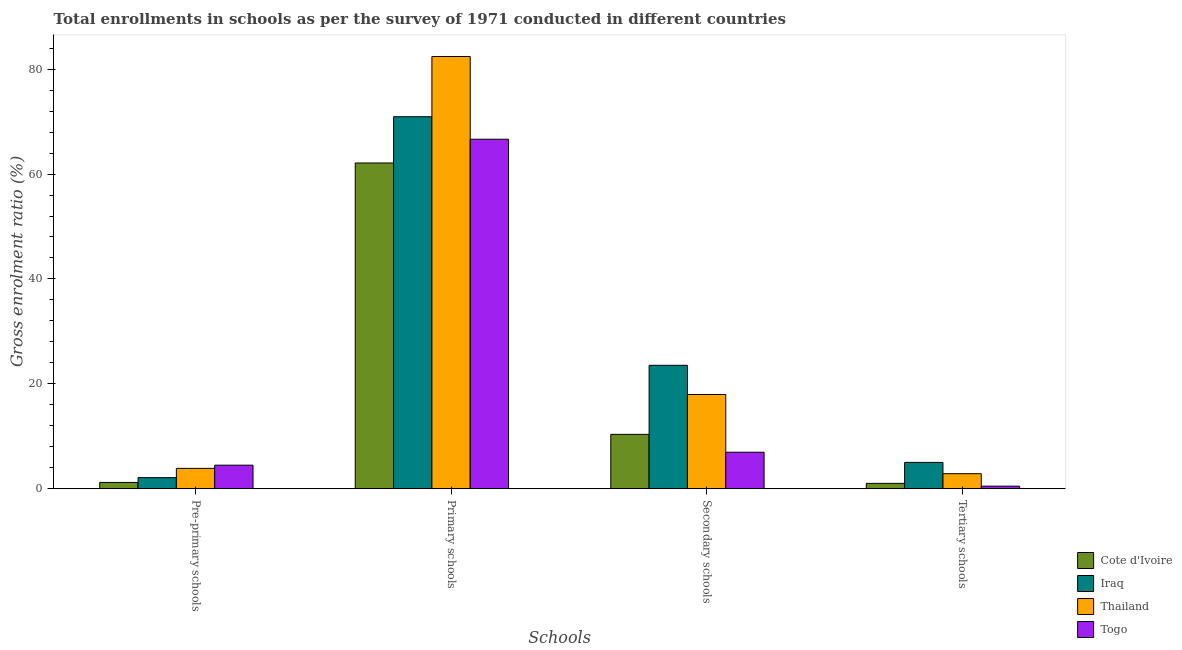How many bars are there on the 1st tick from the right?
Your response must be concise. 4. What is the label of the 2nd group of bars from the left?
Make the answer very short. Primary schools. What is the gross enrolment ratio in primary schools in Thailand?
Ensure brevity in your answer.  82.42. Across all countries, what is the maximum gross enrolment ratio in secondary schools?
Your answer should be very brief. 23.53. Across all countries, what is the minimum gross enrolment ratio in secondary schools?
Offer a very short reply. 6.95. In which country was the gross enrolment ratio in pre-primary schools maximum?
Provide a succinct answer. Togo. In which country was the gross enrolment ratio in secondary schools minimum?
Offer a very short reply. Togo. What is the total gross enrolment ratio in primary schools in the graph?
Provide a succinct answer. 282.12. What is the difference between the gross enrolment ratio in tertiary schools in Thailand and that in Cote d'Ivoire?
Your response must be concise. 1.85. What is the difference between the gross enrolment ratio in secondary schools in Thailand and the gross enrolment ratio in primary schools in Iraq?
Your response must be concise. -52.98. What is the average gross enrolment ratio in primary schools per country?
Give a very brief answer. 70.53. What is the difference between the gross enrolment ratio in primary schools and gross enrolment ratio in tertiary schools in Iraq?
Provide a short and direct response. 65.92. What is the ratio of the gross enrolment ratio in primary schools in Cote d'Ivoire to that in Thailand?
Your answer should be compact. 0.75. Is the gross enrolment ratio in tertiary schools in Togo less than that in Thailand?
Provide a short and direct response. Yes. What is the difference between the highest and the second highest gross enrolment ratio in pre-primary schools?
Make the answer very short. 0.61. What is the difference between the highest and the lowest gross enrolment ratio in tertiary schools?
Ensure brevity in your answer.  4.53. Is the sum of the gross enrolment ratio in primary schools in Thailand and Togo greater than the maximum gross enrolment ratio in tertiary schools across all countries?
Provide a short and direct response. Yes. Is it the case that in every country, the sum of the gross enrolment ratio in primary schools and gross enrolment ratio in tertiary schools is greater than the sum of gross enrolment ratio in pre-primary schools and gross enrolment ratio in secondary schools?
Your response must be concise. Yes. What does the 2nd bar from the left in Pre-primary schools represents?
Your answer should be very brief. Iraq. What does the 3rd bar from the right in Primary schools represents?
Your response must be concise. Iraq. How many bars are there?
Your answer should be very brief. 16. Does the graph contain grids?
Offer a very short reply. No. What is the title of the graph?
Your response must be concise. Total enrollments in schools as per the survey of 1971 conducted in different countries. What is the label or title of the X-axis?
Give a very brief answer. Schools. What is the Gross enrolment ratio (%) of Cote d'Ivoire in Pre-primary schools?
Your answer should be compact. 1.19. What is the Gross enrolment ratio (%) of Iraq in Pre-primary schools?
Give a very brief answer. 2.1. What is the Gross enrolment ratio (%) of Thailand in Pre-primary schools?
Keep it short and to the point. 3.87. What is the Gross enrolment ratio (%) of Togo in Pre-primary schools?
Give a very brief answer. 4.48. What is the Gross enrolment ratio (%) of Cote d'Ivoire in Primary schools?
Make the answer very short. 62.12. What is the Gross enrolment ratio (%) in Iraq in Primary schools?
Your response must be concise. 70.94. What is the Gross enrolment ratio (%) in Thailand in Primary schools?
Your answer should be compact. 82.42. What is the Gross enrolment ratio (%) in Togo in Primary schools?
Offer a terse response. 66.64. What is the Gross enrolment ratio (%) of Cote d'Ivoire in Secondary schools?
Your answer should be compact. 10.36. What is the Gross enrolment ratio (%) in Iraq in Secondary schools?
Your response must be concise. 23.53. What is the Gross enrolment ratio (%) in Thailand in Secondary schools?
Offer a terse response. 17.96. What is the Gross enrolment ratio (%) in Togo in Secondary schools?
Keep it short and to the point. 6.95. What is the Gross enrolment ratio (%) in Cote d'Ivoire in Tertiary schools?
Give a very brief answer. 1.01. What is the Gross enrolment ratio (%) in Iraq in Tertiary schools?
Your answer should be very brief. 5.01. What is the Gross enrolment ratio (%) in Thailand in Tertiary schools?
Make the answer very short. 2.86. What is the Gross enrolment ratio (%) of Togo in Tertiary schools?
Your answer should be very brief. 0.48. Across all Schools, what is the maximum Gross enrolment ratio (%) in Cote d'Ivoire?
Offer a very short reply. 62.12. Across all Schools, what is the maximum Gross enrolment ratio (%) of Iraq?
Your answer should be very brief. 70.94. Across all Schools, what is the maximum Gross enrolment ratio (%) of Thailand?
Keep it short and to the point. 82.42. Across all Schools, what is the maximum Gross enrolment ratio (%) in Togo?
Provide a succinct answer. 66.64. Across all Schools, what is the minimum Gross enrolment ratio (%) of Cote d'Ivoire?
Provide a short and direct response. 1.01. Across all Schools, what is the minimum Gross enrolment ratio (%) in Iraq?
Offer a very short reply. 2.1. Across all Schools, what is the minimum Gross enrolment ratio (%) in Thailand?
Give a very brief answer. 2.86. Across all Schools, what is the minimum Gross enrolment ratio (%) in Togo?
Provide a short and direct response. 0.48. What is the total Gross enrolment ratio (%) in Cote d'Ivoire in the graph?
Your answer should be very brief. 74.67. What is the total Gross enrolment ratio (%) in Iraq in the graph?
Offer a terse response. 101.58. What is the total Gross enrolment ratio (%) of Thailand in the graph?
Give a very brief answer. 107.12. What is the total Gross enrolment ratio (%) of Togo in the graph?
Your answer should be very brief. 78.55. What is the difference between the Gross enrolment ratio (%) in Cote d'Ivoire in Pre-primary schools and that in Primary schools?
Provide a succinct answer. -60.93. What is the difference between the Gross enrolment ratio (%) of Iraq in Pre-primary schools and that in Primary schools?
Offer a terse response. -68.83. What is the difference between the Gross enrolment ratio (%) of Thailand in Pre-primary schools and that in Primary schools?
Your answer should be very brief. -78.55. What is the difference between the Gross enrolment ratio (%) in Togo in Pre-primary schools and that in Primary schools?
Provide a succinct answer. -62.16. What is the difference between the Gross enrolment ratio (%) of Cote d'Ivoire in Pre-primary schools and that in Secondary schools?
Your response must be concise. -9.17. What is the difference between the Gross enrolment ratio (%) of Iraq in Pre-primary schools and that in Secondary schools?
Make the answer very short. -21.42. What is the difference between the Gross enrolment ratio (%) in Thailand in Pre-primary schools and that in Secondary schools?
Your answer should be very brief. -14.09. What is the difference between the Gross enrolment ratio (%) of Togo in Pre-primary schools and that in Secondary schools?
Ensure brevity in your answer.  -2.47. What is the difference between the Gross enrolment ratio (%) in Cote d'Ivoire in Pre-primary schools and that in Tertiary schools?
Provide a short and direct response. 0.18. What is the difference between the Gross enrolment ratio (%) of Iraq in Pre-primary schools and that in Tertiary schools?
Provide a succinct answer. -2.91. What is the difference between the Gross enrolment ratio (%) of Thailand in Pre-primary schools and that in Tertiary schools?
Offer a terse response. 1.02. What is the difference between the Gross enrolment ratio (%) of Togo in Pre-primary schools and that in Tertiary schools?
Offer a very short reply. 4. What is the difference between the Gross enrolment ratio (%) in Cote d'Ivoire in Primary schools and that in Secondary schools?
Your response must be concise. 51.76. What is the difference between the Gross enrolment ratio (%) in Iraq in Primary schools and that in Secondary schools?
Give a very brief answer. 47.41. What is the difference between the Gross enrolment ratio (%) of Thailand in Primary schools and that in Secondary schools?
Your answer should be compact. 64.46. What is the difference between the Gross enrolment ratio (%) of Togo in Primary schools and that in Secondary schools?
Offer a very short reply. 59.69. What is the difference between the Gross enrolment ratio (%) in Cote d'Ivoire in Primary schools and that in Tertiary schools?
Your response must be concise. 61.1. What is the difference between the Gross enrolment ratio (%) of Iraq in Primary schools and that in Tertiary schools?
Give a very brief answer. 65.92. What is the difference between the Gross enrolment ratio (%) in Thailand in Primary schools and that in Tertiary schools?
Provide a short and direct response. 79.57. What is the difference between the Gross enrolment ratio (%) of Togo in Primary schools and that in Tertiary schools?
Provide a succinct answer. 66.16. What is the difference between the Gross enrolment ratio (%) in Cote d'Ivoire in Secondary schools and that in Tertiary schools?
Your answer should be compact. 9.35. What is the difference between the Gross enrolment ratio (%) in Iraq in Secondary schools and that in Tertiary schools?
Offer a very short reply. 18.51. What is the difference between the Gross enrolment ratio (%) of Thailand in Secondary schools and that in Tertiary schools?
Provide a succinct answer. 15.1. What is the difference between the Gross enrolment ratio (%) of Togo in Secondary schools and that in Tertiary schools?
Your response must be concise. 6.47. What is the difference between the Gross enrolment ratio (%) of Cote d'Ivoire in Pre-primary schools and the Gross enrolment ratio (%) of Iraq in Primary schools?
Your answer should be compact. -69.75. What is the difference between the Gross enrolment ratio (%) of Cote d'Ivoire in Pre-primary schools and the Gross enrolment ratio (%) of Thailand in Primary schools?
Your response must be concise. -81.24. What is the difference between the Gross enrolment ratio (%) of Cote d'Ivoire in Pre-primary schools and the Gross enrolment ratio (%) of Togo in Primary schools?
Offer a terse response. -65.46. What is the difference between the Gross enrolment ratio (%) in Iraq in Pre-primary schools and the Gross enrolment ratio (%) in Thailand in Primary schools?
Provide a succinct answer. -80.32. What is the difference between the Gross enrolment ratio (%) in Iraq in Pre-primary schools and the Gross enrolment ratio (%) in Togo in Primary schools?
Offer a terse response. -64.54. What is the difference between the Gross enrolment ratio (%) of Thailand in Pre-primary schools and the Gross enrolment ratio (%) of Togo in Primary schools?
Keep it short and to the point. -62.77. What is the difference between the Gross enrolment ratio (%) in Cote d'Ivoire in Pre-primary schools and the Gross enrolment ratio (%) in Iraq in Secondary schools?
Ensure brevity in your answer.  -22.34. What is the difference between the Gross enrolment ratio (%) of Cote d'Ivoire in Pre-primary schools and the Gross enrolment ratio (%) of Thailand in Secondary schools?
Make the answer very short. -16.77. What is the difference between the Gross enrolment ratio (%) of Cote d'Ivoire in Pre-primary schools and the Gross enrolment ratio (%) of Togo in Secondary schools?
Your response must be concise. -5.76. What is the difference between the Gross enrolment ratio (%) in Iraq in Pre-primary schools and the Gross enrolment ratio (%) in Thailand in Secondary schools?
Give a very brief answer. -15.86. What is the difference between the Gross enrolment ratio (%) in Iraq in Pre-primary schools and the Gross enrolment ratio (%) in Togo in Secondary schools?
Your response must be concise. -4.85. What is the difference between the Gross enrolment ratio (%) in Thailand in Pre-primary schools and the Gross enrolment ratio (%) in Togo in Secondary schools?
Offer a very short reply. -3.08. What is the difference between the Gross enrolment ratio (%) in Cote d'Ivoire in Pre-primary schools and the Gross enrolment ratio (%) in Iraq in Tertiary schools?
Give a very brief answer. -3.82. What is the difference between the Gross enrolment ratio (%) of Cote d'Ivoire in Pre-primary schools and the Gross enrolment ratio (%) of Thailand in Tertiary schools?
Your answer should be compact. -1.67. What is the difference between the Gross enrolment ratio (%) in Cote d'Ivoire in Pre-primary schools and the Gross enrolment ratio (%) in Togo in Tertiary schools?
Make the answer very short. 0.71. What is the difference between the Gross enrolment ratio (%) of Iraq in Pre-primary schools and the Gross enrolment ratio (%) of Thailand in Tertiary schools?
Your response must be concise. -0.75. What is the difference between the Gross enrolment ratio (%) of Iraq in Pre-primary schools and the Gross enrolment ratio (%) of Togo in Tertiary schools?
Your answer should be compact. 1.62. What is the difference between the Gross enrolment ratio (%) of Thailand in Pre-primary schools and the Gross enrolment ratio (%) of Togo in Tertiary schools?
Ensure brevity in your answer.  3.4. What is the difference between the Gross enrolment ratio (%) of Cote d'Ivoire in Primary schools and the Gross enrolment ratio (%) of Iraq in Secondary schools?
Make the answer very short. 38.59. What is the difference between the Gross enrolment ratio (%) in Cote d'Ivoire in Primary schools and the Gross enrolment ratio (%) in Thailand in Secondary schools?
Your answer should be very brief. 44.16. What is the difference between the Gross enrolment ratio (%) of Cote d'Ivoire in Primary schools and the Gross enrolment ratio (%) of Togo in Secondary schools?
Provide a succinct answer. 55.16. What is the difference between the Gross enrolment ratio (%) in Iraq in Primary schools and the Gross enrolment ratio (%) in Thailand in Secondary schools?
Provide a succinct answer. 52.98. What is the difference between the Gross enrolment ratio (%) in Iraq in Primary schools and the Gross enrolment ratio (%) in Togo in Secondary schools?
Make the answer very short. 63.99. What is the difference between the Gross enrolment ratio (%) of Thailand in Primary schools and the Gross enrolment ratio (%) of Togo in Secondary schools?
Offer a very short reply. 75.47. What is the difference between the Gross enrolment ratio (%) of Cote d'Ivoire in Primary schools and the Gross enrolment ratio (%) of Iraq in Tertiary schools?
Your response must be concise. 57.1. What is the difference between the Gross enrolment ratio (%) of Cote d'Ivoire in Primary schools and the Gross enrolment ratio (%) of Thailand in Tertiary schools?
Offer a very short reply. 59.26. What is the difference between the Gross enrolment ratio (%) of Cote d'Ivoire in Primary schools and the Gross enrolment ratio (%) of Togo in Tertiary schools?
Ensure brevity in your answer.  61.64. What is the difference between the Gross enrolment ratio (%) of Iraq in Primary schools and the Gross enrolment ratio (%) of Thailand in Tertiary schools?
Keep it short and to the point. 68.08. What is the difference between the Gross enrolment ratio (%) in Iraq in Primary schools and the Gross enrolment ratio (%) in Togo in Tertiary schools?
Offer a terse response. 70.46. What is the difference between the Gross enrolment ratio (%) in Thailand in Primary schools and the Gross enrolment ratio (%) in Togo in Tertiary schools?
Provide a short and direct response. 81.94. What is the difference between the Gross enrolment ratio (%) in Cote d'Ivoire in Secondary schools and the Gross enrolment ratio (%) in Iraq in Tertiary schools?
Make the answer very short. 5.35. What is the difference between the Gross enrolment ratio (%) in Cote d'Ivoire in Secondary schools and the Gross enrolment ratio (%) in Thailand in Tertiary schools?
Give a very brief answer. 7.5. What is the difference between the Gross enrolment ratio (%) of Cote d'Ivoire in Secondary schools and the Gross enrolment ratio (%) of Togo in Tertiary schools?
Your answer should be compact. 9.88. What is the difference between the Gross enrolment ratio (%) of Iraq in Secondary schools and the Gross enrolment ratio (%) of Thailand in Tertiary schools?
Give a very brief answer. 20.67. What is the difference between the Gross enrolment ratio (%) in Iraq in Secondary schools and the Gross enrolment ratio (%) in Togo in Tertiary schools?
Your answer should be compact. 23.05. What is the difference between the Gross enrolment ratio (%) of Thailand in Secondary schools and the Gross enrolment ratio (%) of Togo in Tertiary schools?
Ensure brevity in your answer.  17.48. What is the average Gross enrolment ratio (%) of Cote d'Ivoire per Schools?
Offer a very short reply. 18.67. What is the average Gross enrolment ratio (%) of Iraq per Schools?
Make the answer very short. 25.39. What is the average Gross enrolment ratio (%) in Thailand per Schools?
Offer a very short reply. 26.78. What is the average Gross enrolment ratio (%) of Togo per Schools?
Offer a very short reply. 19.64. What is the difference between the Gross enrolment ratio (%) of Cote d'Ivoire and Gross enrolment ratio (%) of Iraq in Pre-primary schools?
Keep it short and to the point. -0.92. What is the difference between the Gross enrolment ratio (%) in Cote d'Ivoire and Gross enrolment ratio (%) in Thailand in Pre-primary schools?
Ensure brevity in your answer.  -2.69. What is the difference between the Gross enrolment ratio (%) of Cote d'Ivoire and Gross enrolment ratio (%) of Togo in Pre-primary schools?
Offer a very short reply. -3.29. What is the difference between the Gross enrolment ratio (%) of Iraq and Gross enrolment ratio (%) of Thailand in Pre-primary schools?
Your answer should be very brief. -1.77. What is the difference between the Gross enrolment ratio (%) in Iraq and Gross enrolment ratio (%) in Togo in Pre-primary schools?
Make the answer very short. -2.38. What is the difference between the Gross enrolment ratio (%) of Thailand and Gross enrolment ratio (%) of Togo in Pre-primary schools?
Ensure brevity in your answer.  -0.61. What is the difference between the Gross enrolment ratio (%) in Cote d'Ivoire and Gross enrolment ratio (%) in Iraq in Primary schools?
Ensure brevity in your answer.  -8.82. What is the difference between the Gross enrolment ratio (%) of Cote d'Ivoire and Gross enrolment ratio (%) of Thailand in Primary schools?
Provide a succinct answer. -20.31. What is the difference between the Gross enrolment ratio (%) in Cote d'Ivoire and Gross enrolment ratio (%) in Togo in Primary schools?
Offer a very short reply. -4.53. What is the difference between the Gross enrolment ratio (%) in Iraq and Gross enrolment ratio (%) in Thailand in Primary schools?
Offer a terse response. -11.49. What is the difference between the Gross enrolment ratio (%) of Iraq and Gross enrolment ratio (%) of Togo in Primary schools?
Provide a succinct answer. 4.29. What is the difference between the Gross enrolment ratio (%) of Thailand and Gross enrolment ratio (%) of Togo in Primary schools?
Keep it short and to the point. 15.78. What is the difference between the Gross enrolment ratio (%) in Cote d'Ivoire and Gross enrolment ratio (%) in Iraq in Secondary schools?
Provide a short and direct response. -13.17. What is the difference between the Gross enrolment ratio (%) of Cote d'Ivoire and Gross enrolment ratio (%) of Thailand in Secondary schools?
Offer a very short reply. -7.6. What is the difference between the Gross enrolment ratio (%) of Cote d'Ivoire and Gross enrolment ratio (%) of Togo in Secondary schools?
Provide a short and direct response. 3.41. What is the difference between the Gross enrolment ratio (%) in Iraq and Gross enrolment ratio (%) in Thailand in Secondary schools?
Offer a terse response. 5.57. What is the difference between the Gross enrolment ratio (%) in Iraq and Gross enrolment ratio (%) in Togo in Secondary schools?
Your answer should be compact. 16.58. What is the difference between the Gross enrolment ratio (%) of Thailand and Gross enrolment ratio (%) of Togo in Secondary schools?
Offer a very short reply. 11.01. What is the difference between the Gross enrolment ratio (%) of Cote d'Ivoire and Gross enrolment ratio (%) of Iraq in Tertiary schools?
Your answer should be very brief. -4. What is the difference between the Gross enrolment ratio (%) in Cote d'Ivoire and Gross enrolment ratio (%) in Thailand in Tertiary schools?
Offer a very short reply. -1.85. What is the difference between the Gross enrolment ratio (%) of Cote d'Ivoire and Gross enrolment ratio (%) of Togo in Tertiary schools?
Offer a terse response. 0.53. What is the difference between the Gross enrolment ratio (%) in Iraq and Gross enrolment ratio (%) in Thailand in Tertiary schools?
Provide a succinct answer. 2.15. What is the difference between the Gross enrolment ratio (%) of Iraq and Gross enrolment ratio (%) of Togo in Tertiary schools?
Provide a short and direct response. 4.53. What is the difference between the Gross enrolment ratio (%) in Thailand and Gross enrolment ratio (%) in Togo in Tertiary schools?
Offer a terse response. 2.38. What is the ratio of the Gross enrolment ratio (%) of Cote d'Ivoire in Pre-primary schools to that in Primary schools?
Your answer should be compact. 0.02. What is the ratio of the Gross enrolment ratio (%) of Iraq in Pre-primary schools to that in Primary schools?
Keep it short and to the point. 0.03. What is the ratio of the Gross enrolment ratio (%) of Thailand in Pre-primary schools to that in Primary schools?
Offer a very short reply. 0.05. What is the ratio of the Gross enrolment ratio (%) of Togo in Pre-primary schools to that in Primary schools?
Offer a very short reply. 0.07. What is the ratio of the Gross enrolment ratio (%) of Cote d'Ivoire in Pre-primary schools to that in Secondary schools?
Your answer should be very brief. 0.11. What is the ratio of the Gross enrolment ratio (%) of Iraq in Pre-primary schools to that in Secondary schools?
Offer a terse response. 0.09. What is the ratio of the Gross enrolment ratio (%) of Thailand in Pre-primary schools to that in Secondary schools?
Your response must be concise. 0.22. What is the ratio of the Gross enrolment ratio (%) of Togo in Pre-primary schools to that in Secondary schools?
Your answer should be compact. 0.64. What is the ratio of the Gross enrolment ratio (%) of Cote d'Ivoire in Pre-primary schools to that in Tertiary schools?
Your answer should be very brief. 1.17. What is the ratio of the Gross enrolment ratio (%) of Iraq in Pre-primary schools to that in Tertiary schools?
Your answer should be very brief. 0.42. What is the ratio of the Gross enrolment ratio (%) in Thailand in Pre-primary schools to that in Tertiary schools?
Offer a terse response. 1.36. What is the ratio of the Gross enrolment ratio (%) in Togo in Pre-primary schools to that in Tertiary schools?
Offer a terse response. 9.36. What is the ratio of the Gross enrolment ratio (%) in Cote d'Ivoire in Primary schools to that in Secondary schools?
Your answer should be compact. 6. What is the ratio of the Gross enrolment ratio (%) of Iraq in Primary schools to that in Secondary schools?
Make the answer very short. 3.02. What is the ratio of the Gross enrolment ratio (%) of Thailand in Primary schools to that in Secondary schools?
Your answer should be compact. 4.59. What is the ratio of the Gross enrolment ratio (%) in Togo in Primary schools to that in Secondary schools?
Provide a succinct answer. 9.59. What is the ratio of the Gross enrolment ratio (%) of Cote d'Ivoire in Primary schools to that in Tertiary schools?
Provide a short and direct response. 61.33. What is the ratio of the Gross enrolment ratio (%) in Iraq in Primary schools to that in Tertiary schools?
Provide a short and direct response. 14.15. What is the ratio of the Gross enrolment ratio (%) in Thailand in Primary schools to that in Tertiary schools?
Provide a short and direct response. 28.84. What is the ratio of the Gross enrolment ratio (%) in Togo in Primary schools to that in Tertiary schools?
Give a very brief answer. 139.14. What is the ratio of the Gross enrolment ratio (%) in Cote d'Ivoire in Secondary schools to that in Tertiary schools?
Offer a very short reply. 10.23. What is the ratio of the Gross enrolment ratio (%) of Iraq in Secondary schools to that in Tertiary schools?
Provide a succinct answer. 4.69. What is the ratio of the Gross enrolment ratio (%) in Thailand in Secondary schools to that in Tertiary schools?
Provide a short and direct response. 6.28. What is the ratio of the Gross enrolment ratio (%) in Togo in Secondary schools to that in Tertiary schools?
Make the answer very short. 14.51. What is the difference between the highest and the second highest Gross enrolment ratio (%) of Cote d'Ivoire?
Provide a succinct answer. 51.76. What is the difference between the highest and the second highest Gross enrolment ratio (%) in Iraq?
Your response must be concise. 47.41. What is the difference between the highest and the second highest Gross enrolment ratio (%) of Thailand?
Give a very brief answer. 64.46. What is the difference between the highest and the second highest Gross enrolment ratio (%) of Togo?
Offer a very short reply. 59.69. What is the difference between the highest and the lowest Gross enrolment ratio (%) in Cote d'Ivoire?
Make the answer very short. 61.1. What is the difference between the highest and the lowest Gross enrolment ratio (%) of Iraq?
Your response must be concise. 68.83. What is the difference between the highest and the lowest Gross enrolment ratio (%) in Thailand?
Offer a terse response. 79.57. What is the difference between the highest and the lowest Gross enrolment ratio (%) of Togo?
Provide a succinct answer. 66.16. 